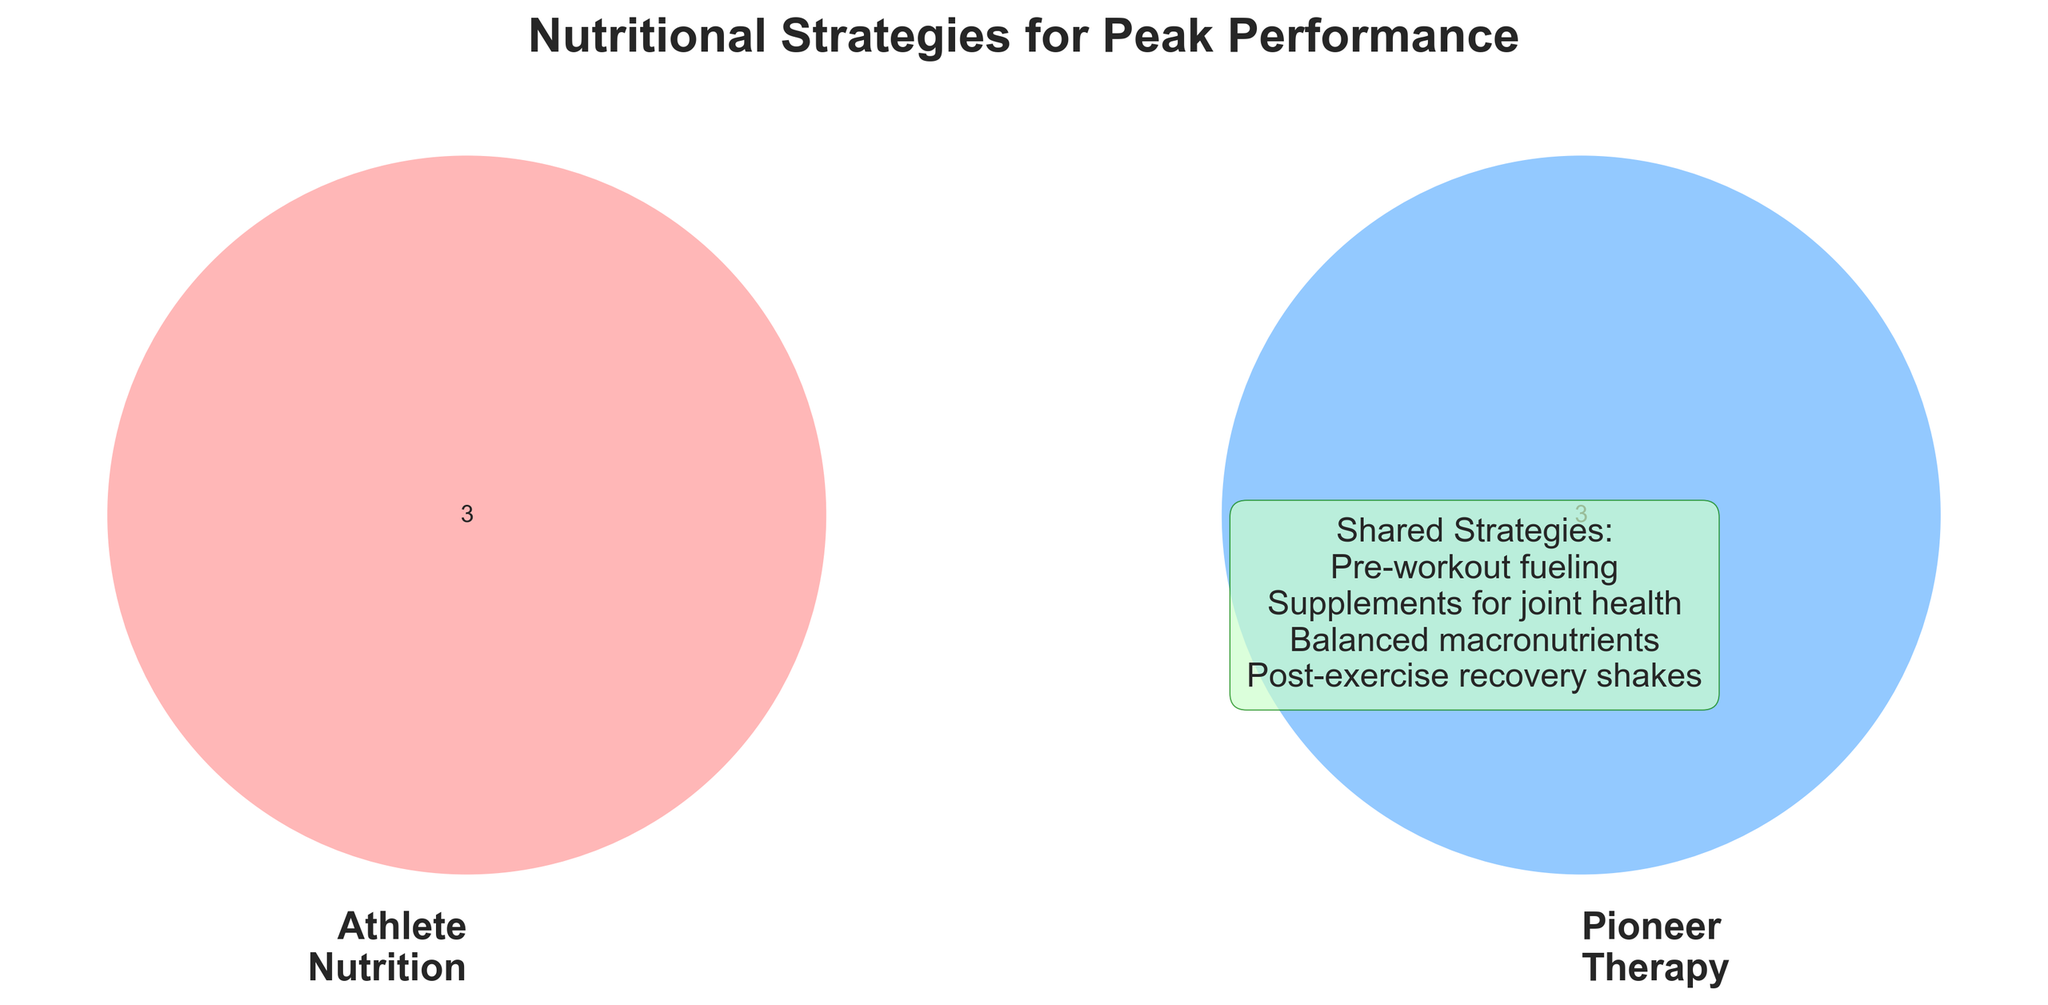What's the title of the figure? The title is usually at the top of the figure and centers itself as a concise descriptor of the content. In this case, it is displayed prominently in bold text.
Answer: Nutritional Strategies for Peak Performance Which strategies are categorized under "Athlete Nutrition"? These are listed within the Athlete Nutrition circle of the Venn Diagram. Look for the items typically belonging to training diets.
Answer: Protein-rich meals, Hydration planning, Carb loading Which strategies are shared between both "Athlete Nutrition" and "Pioneer Therapy"? Items in the overlapping section or the shared strategies listed at the bottom of the figure describe common elements between both categories.
Answer: Pre-workout fueling, Post-exercise recovery shakes, Balanced macronutrients, Supplements for joint health How many strategies are unique to "Pioneer Therapy"? Count the number of items only within the Pioneer Therapy circle, excluding the shared strategies and Athlete Nutrition strategies.
Answer: 3 What colors represent "Athlete Nutrition" and "Pioneer Therapy"? Check the color labels or the Venn Diagram areas. The colors will differ between the categories.
Answer: Red (for Athlete Nutrition) and Blue (for Pioneer Therapy) How does the number of shared strategies compare to those unique to "Athlete Nutrition"? Count the strategies in the shared section and compare it to those in the Athlete Nutrition section only.
Answer: There are 4 shared strategies and 3 unique to Athlete Nutrition What can we infer from the shared strategies listed at the bottom of the figure? These are elements that both categories agree upon or utilize, typically important for overall performance.
Answer: These strategies are critical for both athlete nutrition and pioneer therapy What is the total number of strategies listed in the figure? Count all unique items across both categories and the shared section. No overlap counts twice.
Answer: 10 Which area has the larger font size, the labels or the shared strategies text? Observe the relative font sizes of the label names in the Venn circles and the text listing shared strategies.
Answer: The labels have a larger font size 